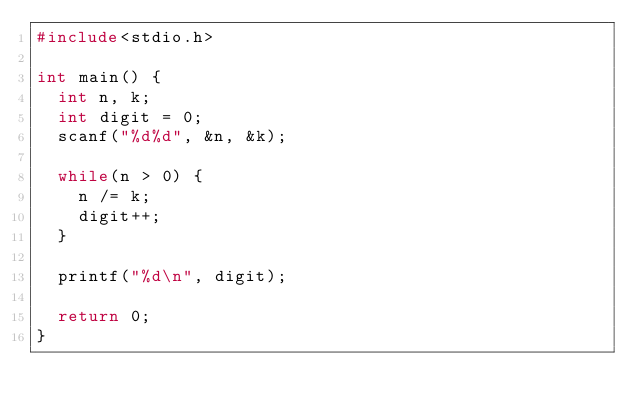Convert code to text. <code><loc_0><loc_0><loc_500><loc_500><_C_>#include<stdio.h>

int main() {
  int n, k;
  int digit = 0;
  scanf("%d%d", &n, &k);
  
  while(n > 0) {
    n /= k;
    digit++;
  }
  
  printf("%d\n", digit);
  
  return 0;
}</code> 